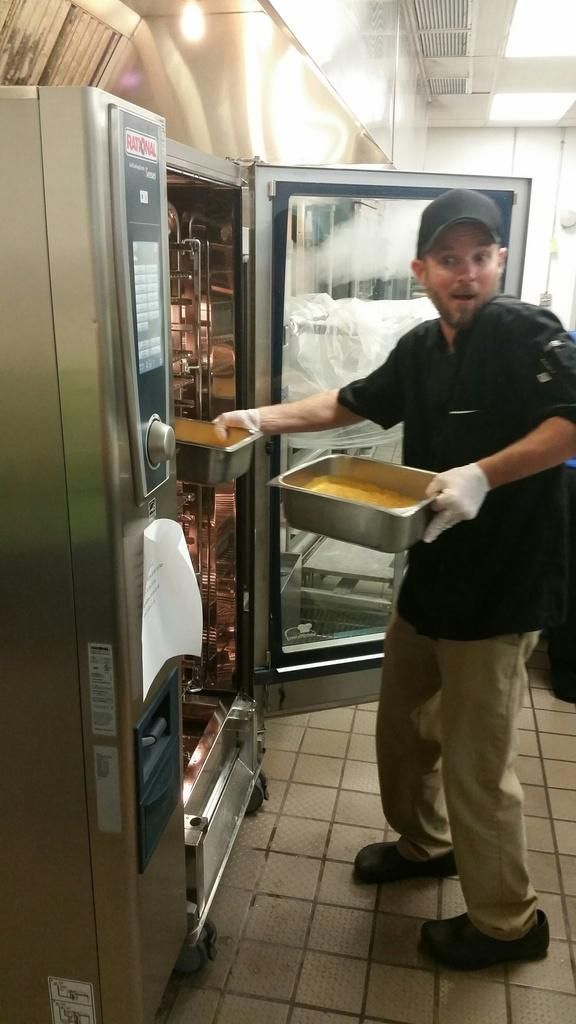What is the main subject of the image? The main subject of the image is a man standing in the middle. What is the man doing in the image? The man is placing vessels in a machine. Can you describe the man's clothing in the image? The man is wearing a black t-shirt and a cap. What type of guitar is the man playing in the image? There is no guitar present in the image; the man is placing vessels in a machine. What government policy is being discussed in the image? There is no discussion of government policy in the image; it focuses on the man placing vessels in a machine. 